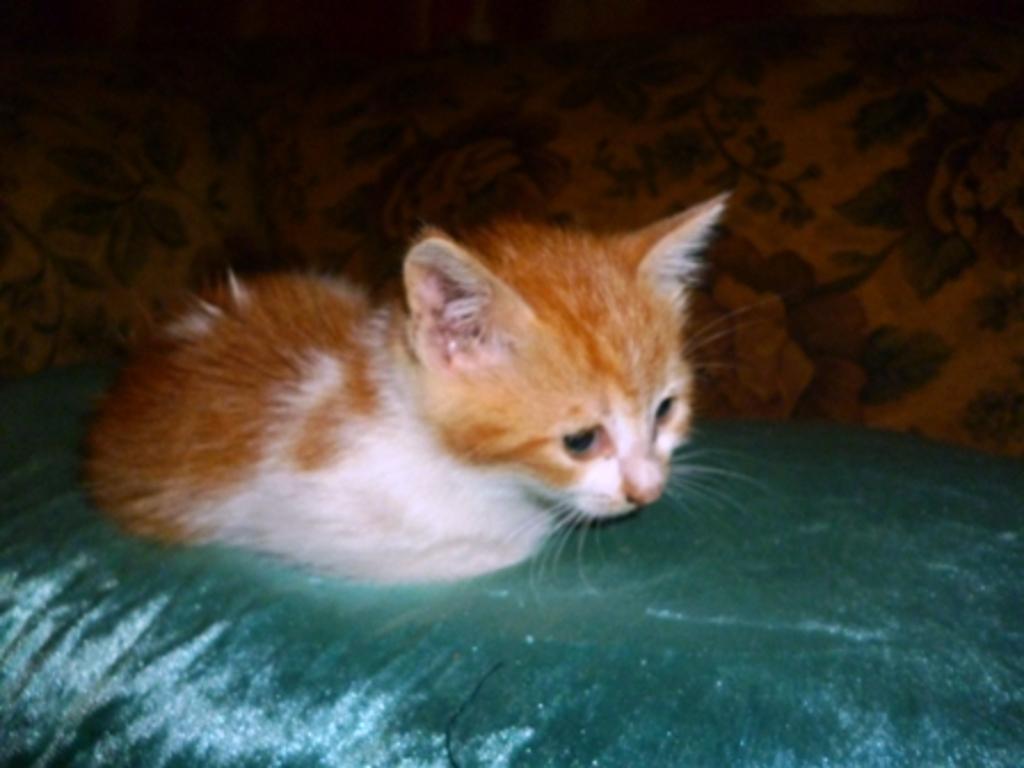In one or two sentences, can you explain what this image depicts? In this image, we can see a brown and white color cat. 